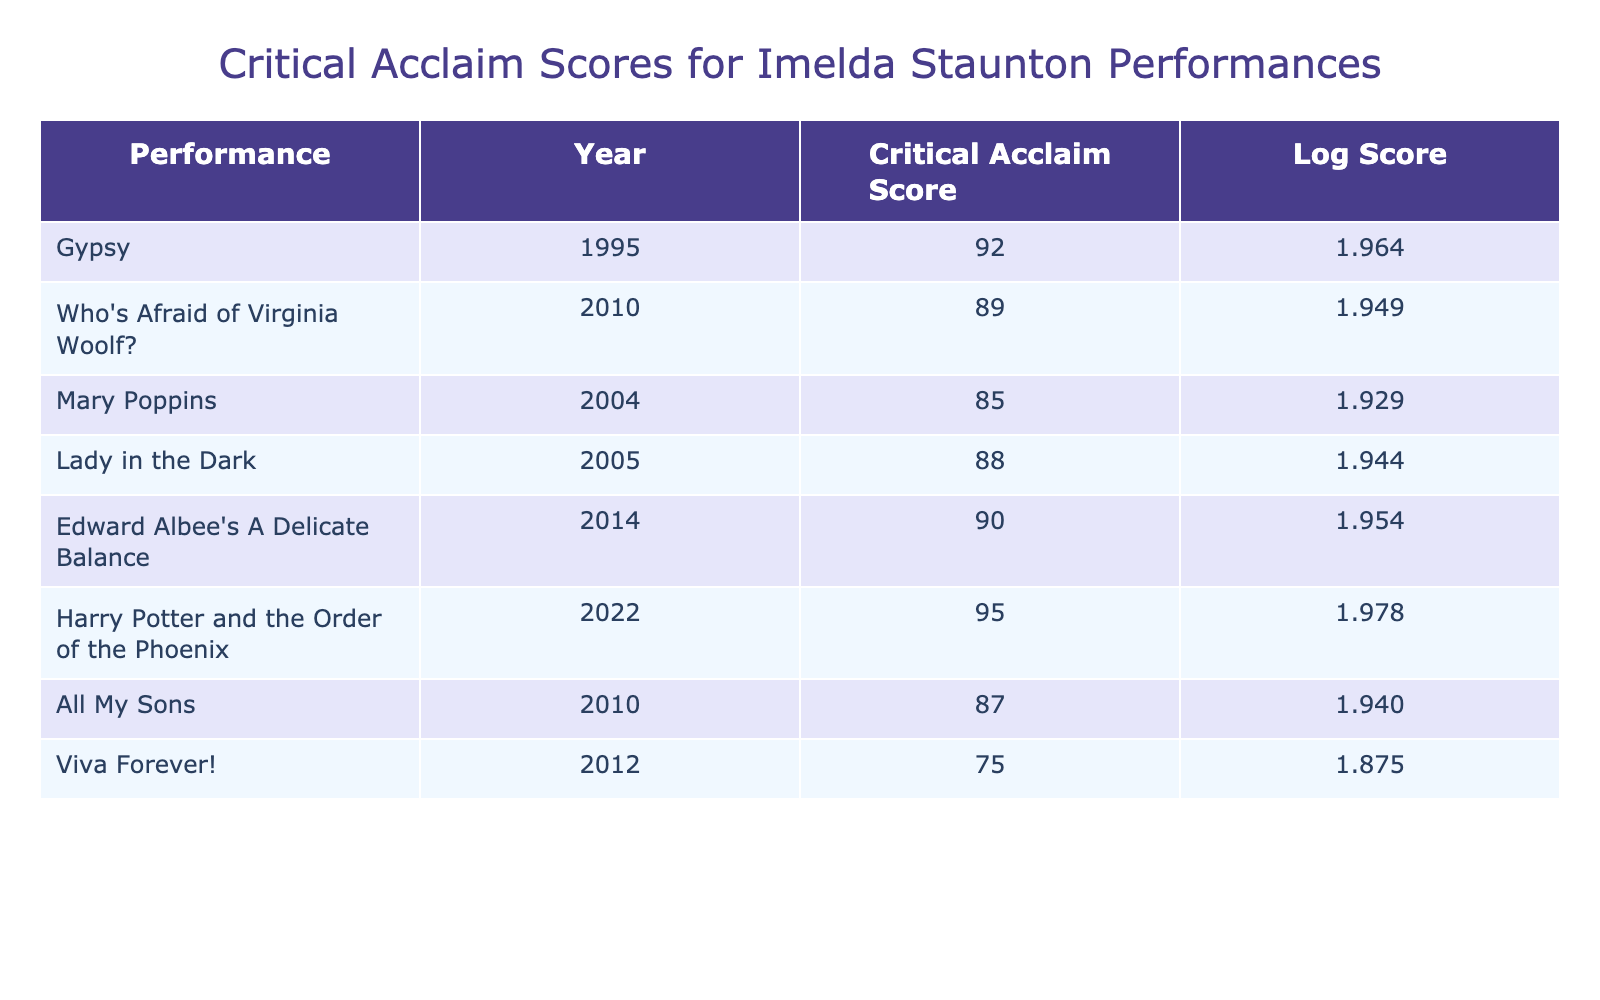What is the Critical Acclaim Score for "Gypsy"? The table lists the Critical Acclaim Score for "Gypsy" as 92.
Answer: 92 Which performance had the highest Critical Acclaim Score? The table indicates that "Harry Potter and the Order of the Phoenix" has the highest Critical Acclaim Score at 95.
Answer: "Harry Potter and the Order of the Phoenix" What is the average Critical Acclaim Score for all performances listed? To find the average, add the scores: 92 + 89 + 85 + 88 + 90 + 95 + 87 + 75 = 706. There are 8 performances, so the average is 706/8 = 88.25.
Answer: 88.25 Did "Mary Poppins" receive a higher score than "Viva Forever!"? The Critical Acclaim Score for "Mary Poppins" is 85, while "Viva Forever!" received a score of 75. Since 85 is greater than 75, the statement is true.
Answer: Yes How many performances scored above 90? The performances that scored above 90 are "Gypsy" (92), "Edward Albee's A Delicate Balance" (90), and "Harry Potter and the Order of the Phoenix" (95). This makes a total of 3 performances.
Answer: 3 Was the score for "All My Sons" lower than the average score? The Critical Acclaim Score for "All My Sons" is 87, which is lower than the average score of 88.25. Therefore, the statement is true.
Answer: Yes What is the difference between the scores of "Lady in the Dark" and "Who's Afraid of Virginia Woolf?" "Lady in the Dark" has a score of 88 and "Who's Afraid of Virginia Woolf?" has a score of 89. The difference is 89 - 88 = 1.
Answer: 1 List the performance(s) that received a score below 80. Looking at the table, the only performance that received a score below 80 is "Viva Forever!" with a score of 75.
Answer: "Viva Forever!" Which year saw the performance with the second-highest Critical Acclaim Score? The second-highest score is 92 for "Gypsy," which was performed in 1995. Therefore, 1995 is the year that saw the second-highest score.
Answer: 1995 